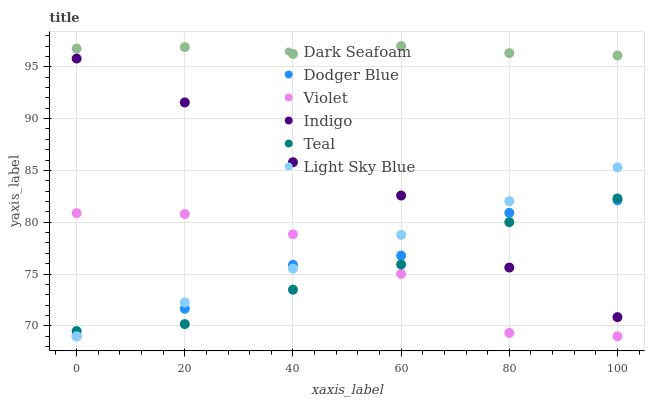Does Teal have the minimum area under the curve?
Answer yes or no. Yes. Does Dark Seafoam have the maximum area under the curve?
Answer yes or no. Yes. Does Light Sky Blue have the minimum area under the curve?
Answer yes or no. No. Does Light Sky Blue have the maximum area under the curve?
Answer yes or no. No. Is Light Sky Blue the smoothest?
Answer yes or no. Yes. Is Dodger Blue the roughest?
Answer yes or no. Yes. Is Dark Seafoam the smoothest?
Answer yes or no. No. Is Dark Seafoam the roughest?
Answer yes or no. No. Does Light Sky Blue have the lowest value?
Answer yes or no. Yes. Does Dark Seafoam have the lowest value?
Answer yes or no. No. Does Dark Seafoam have the highest value?
Answer yes or no. Yes. Does Light Sky Blue have the highest value?
Answer yes or no. No. Is Indigo less than Dark Seafoam?
Answer yes or no. Yes. Is Dark Seafoam greater than Dodger Blue?
Answer yes or no. Yes. Does Dodger Blue intersect Teal?
Answer yes or no. Yes. Is Dodger Blue less than Teal?
Answer yes or no. No. Is Dodger Blue greater than Teal?
Answer yes or no. No. Does Indigo intersect Dark Seafoam?
Answer yes or no. No. 